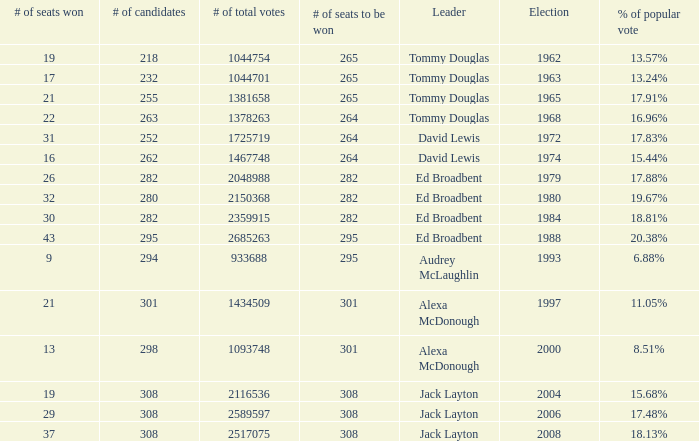Name the number of leaders for % of popular vote being 11.05% 1.0. 